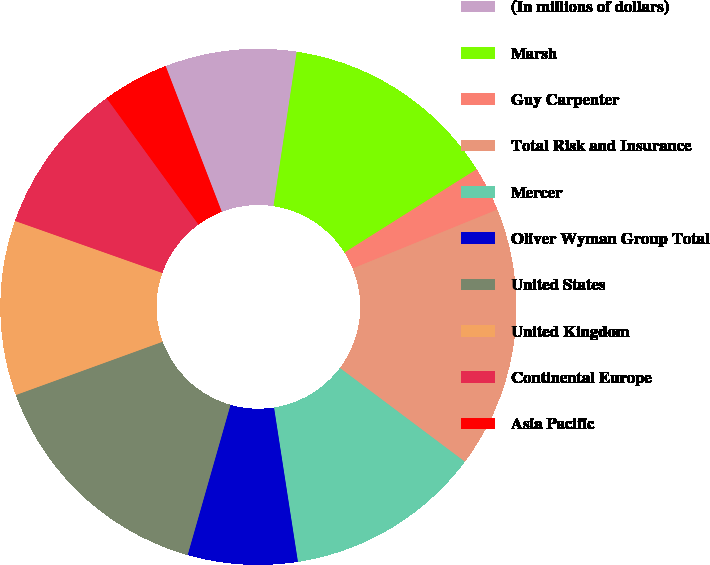<chart> <loc_0><loc_0><loc_500><loc_500><pie_chart><fcel>(In millions of dollars)<fcel>Marsh<fcel>Guy Carpenter<fcel>Total Risk and Insurance<fcel>Mercer<fcel>Oliver Wyman Group Total<fcel>United States<fcel>United Kingdom<fcel>Continental Europe<fcel>Asia Pacific<nl><fcel>8.23%<fcel>13.67%<fcel>2.8%<fcel>16.39%<fcel>12.31%<fcel>6.87%<fcel>15.03%<fcel>10.95%<fcel>9.59%<fcel>4.15%<nl></chart> 